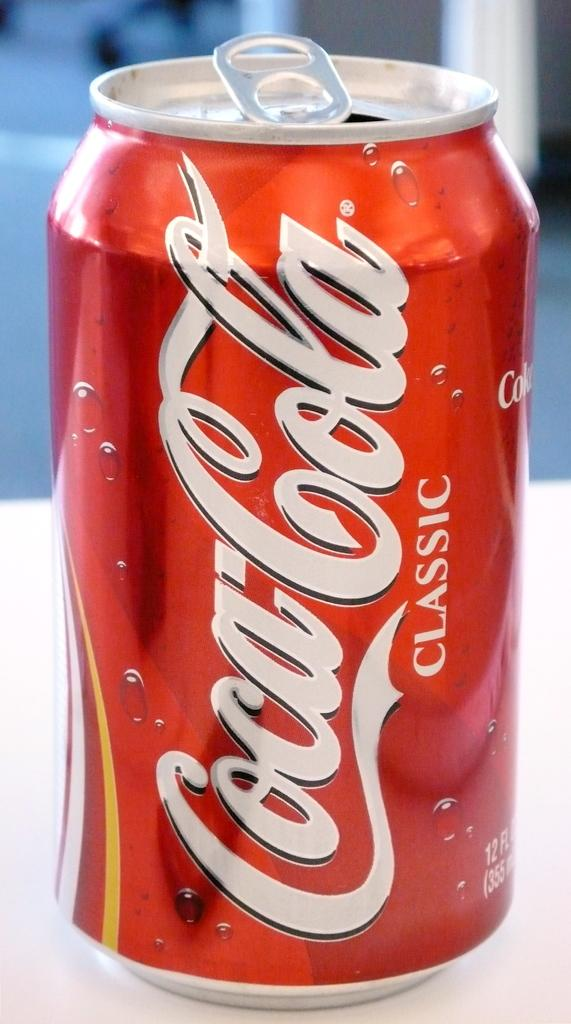<image>
Present a compact description of the photo's key features. A small red coke can that is open. 